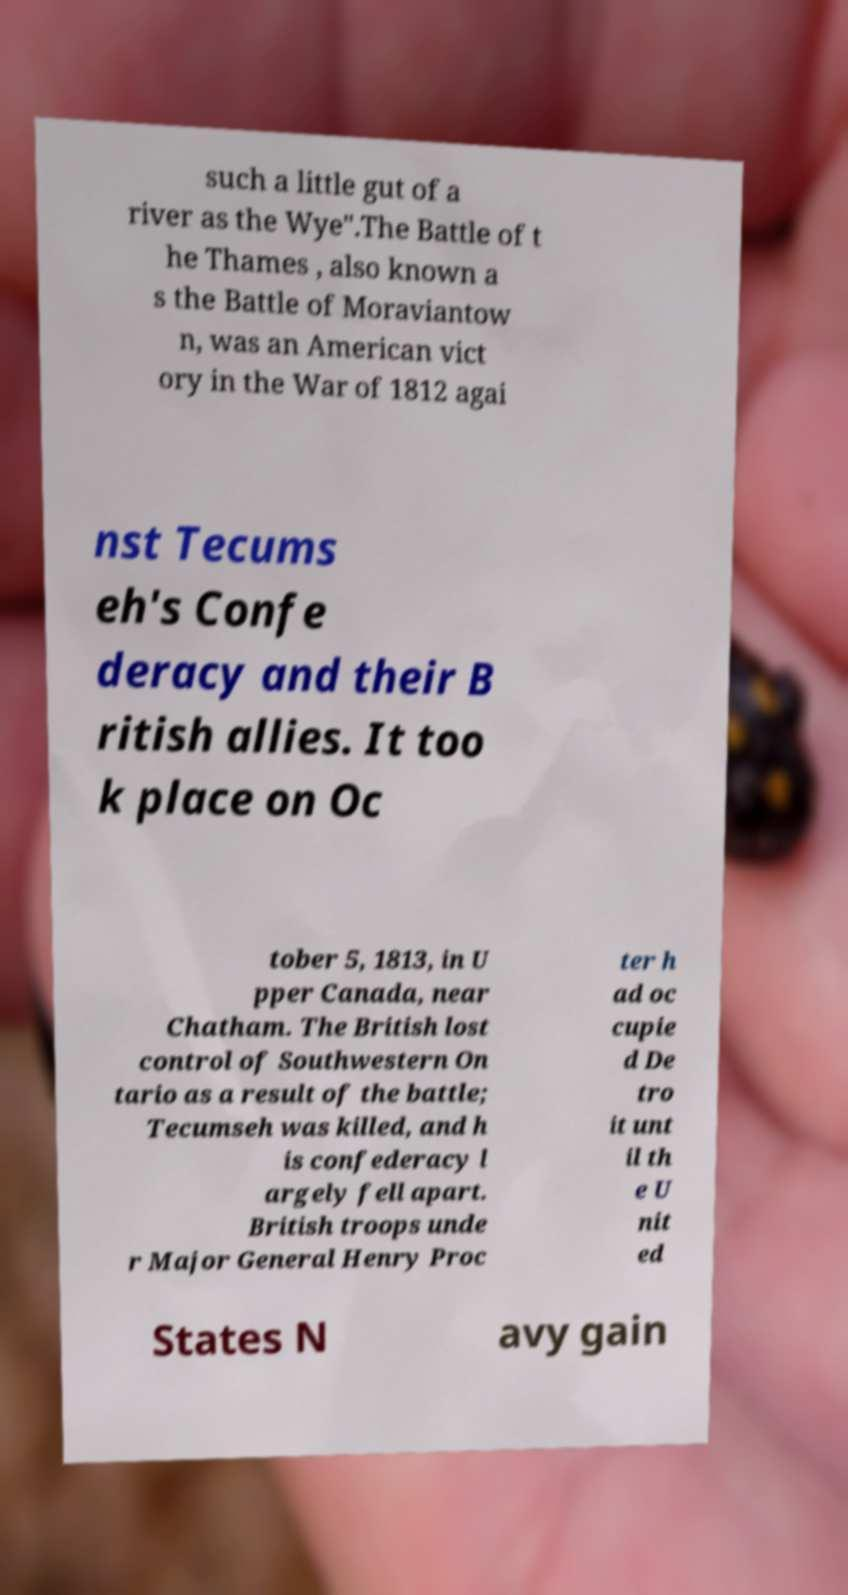Could you extract and type out the text from this image? such a little gut of a river as the Wye".The Battle of t he Thames , also known a s the Battle of Moraviantow n, was an American vict ory in the War of 1812 agai nst Tecums eh's Confe deracy and their B ritish allies. It too k place on Oc tober 5, 1813, in U pper Canada, near Chatham. The British lost control of Southwestern On tario as a result of the battle; Tecumseh was killed, and h is confederacy l argely fell apart. British troops unde r Major General Henry Proc ter h ad oc cupie d De tro it unt il th e U nit ed States N avy gain 